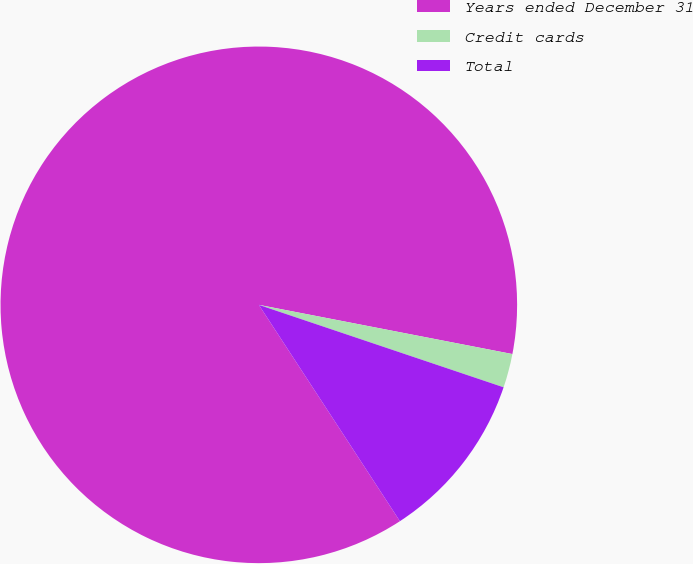Convert chart. <chart><loc_0><loc_0><loc_500><loc_500><pie_chart><fcel>Years ended December 31<fcel>Credit cards<fcel>Total<nl><fcel>87.24%<fcel>2.12%<fcel>10.63%<nl></chart> 